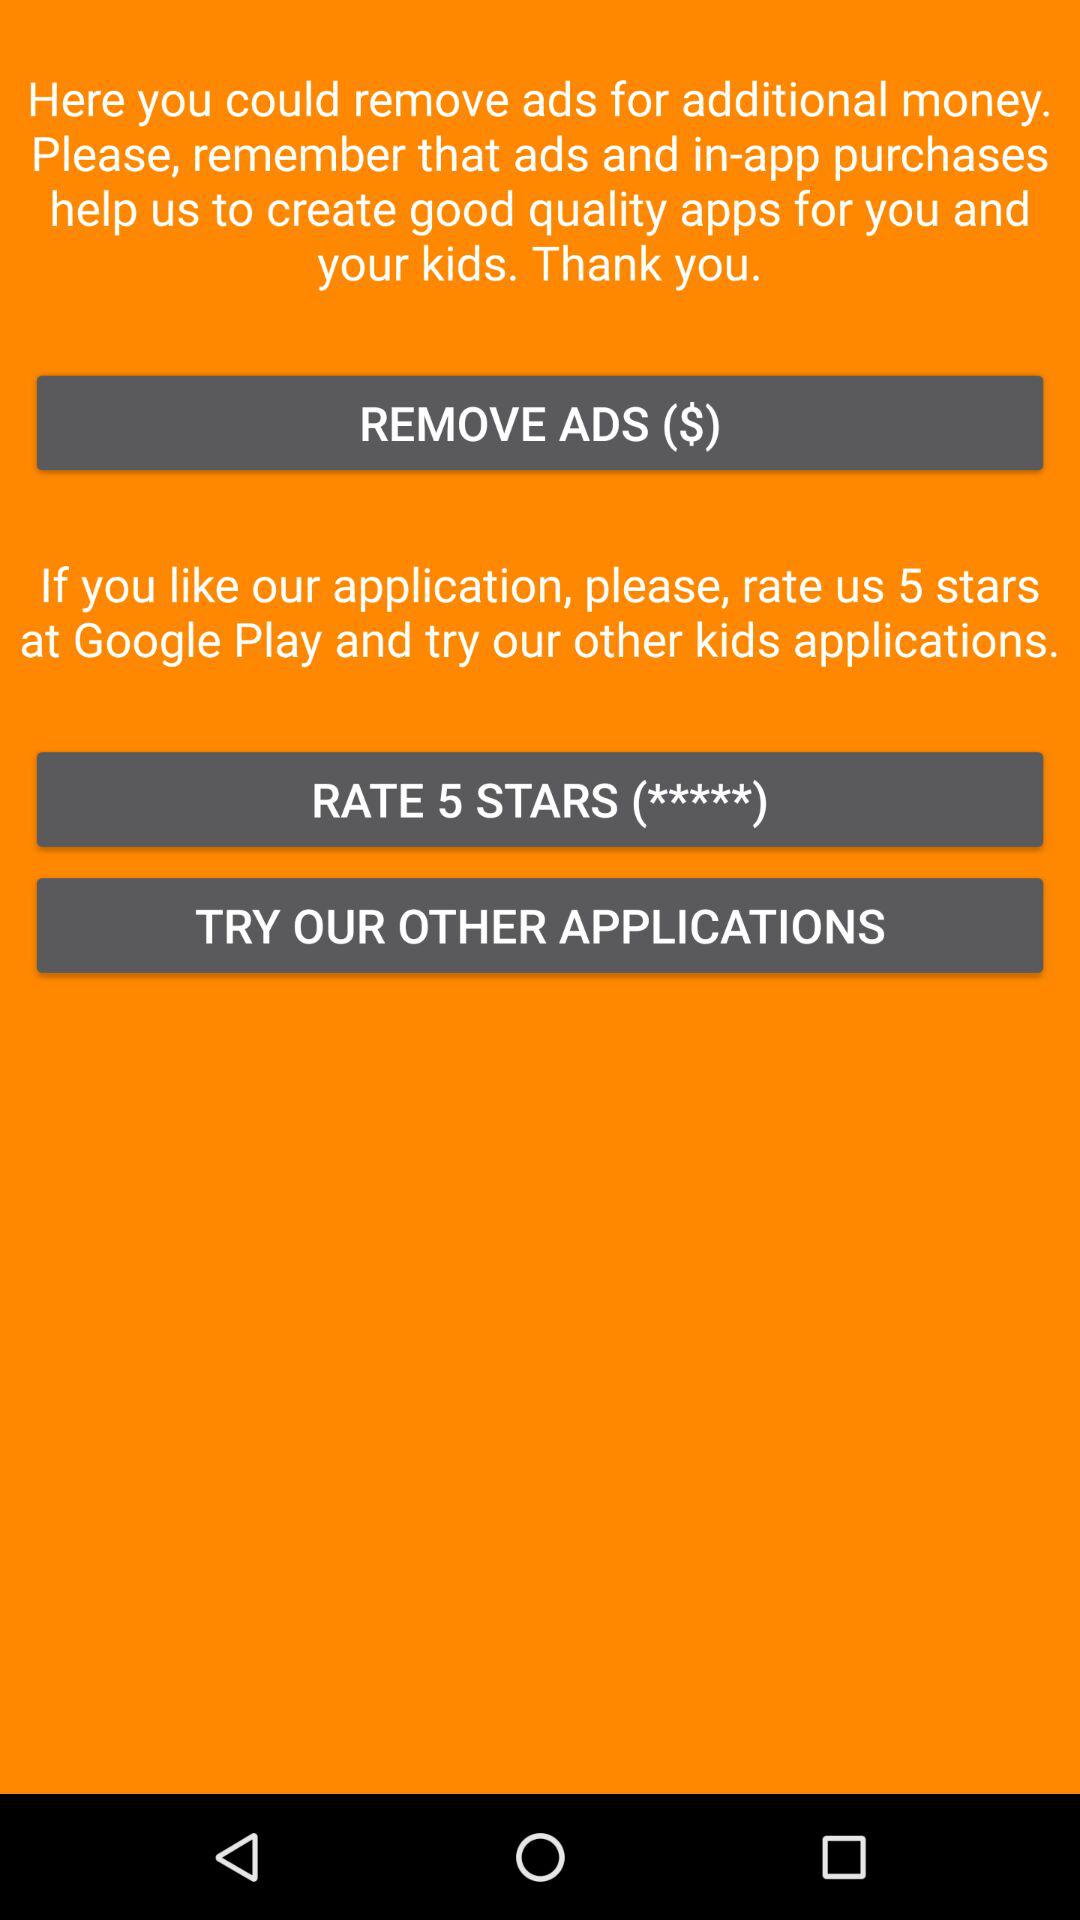On which platform can we rate the application? You can rate the application on "Google Play". 